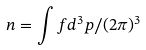<formula> <loc_0><loc_0><loc_500><loc_500>n = \int f d ^ { 3 } p / ( 2 \pi ) ^ { 3 }</formula> 